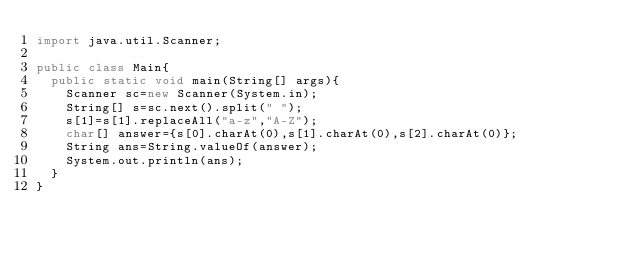<code> <loc_0><loc_0><loc_500><loc_500><_Java_>import java.util.Scanner;

public class Main{
  public static void main(String[] args){
    Scanner sc=new Scanner(System.in);
    String[] s=sc.next().split(" ");
    s[1]=s[1].replaceAll("a-z","A-Z");
    char[] answer={s[0].charAt(0),s[1].charAt(0),s[2].charAt(0)};
    String ans=String.valueOf(answer);
    System.out.println(ans);
  }
}</code> 